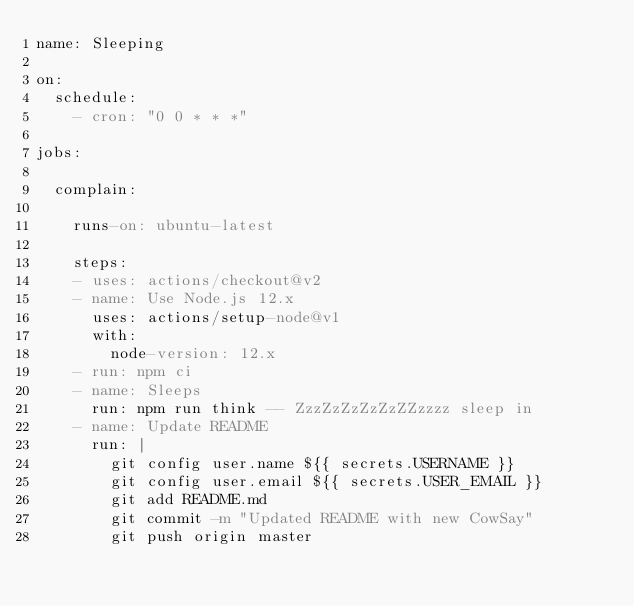Convert code to text. <code><loc_0><loc_0><loc_500><loc_500><_YAML_>name: Sleeping

on:
  schedule:
    - cron: "0 0 * * *"
      
jobs:

  complain:

    runs-on: ubuntu-latest

    steps:
    - uses: actions/checkout@v2
    - name: Use Node.js 12.x
      uses: actions/setup-node@v1
      with:
        node-version: 12.x
    - run: npm ci
    - name: Sleeps
      run: npm run think -- ZzzZzZzZzZzZZzzzz sleep in
    - name: Update README
      run: |
        git config user.name ${{ secrets.USERNAME }}
        git config user.email ${{ secrets.USER_EMAIL }}
        git add README.md
        git commit -m "Updated README with new CowSay"
        git push origin master
</code> 